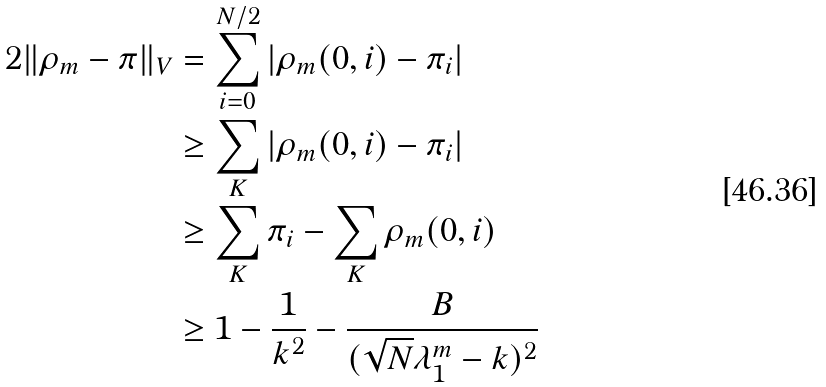<formula> <loc_0><loc_0><loc_500><loc_500>2 \| \rho _ { m } - \pi \| _ { V } & = \sum _ { i = 0 } ^ { N / 2 } | \rho _ { m } ( 0 , i ) - \pi _ { i } | \\ & \geq \sum _ { K } | \rho _ { m } ( 0 , i ) - \pi _ { i } | \\ & \geq \sum _ { K } \pi _ { i } - \sum _ { K } \rho _ { m } ( 0 , i ) \\ & \geq 1 - \frac { 1 } { k ^ { 2 } } - \frac { B } { ( \sqrt { N } \lambda _ { 1 } ^ { m } - k ) ^ { 2 } }</formula> 